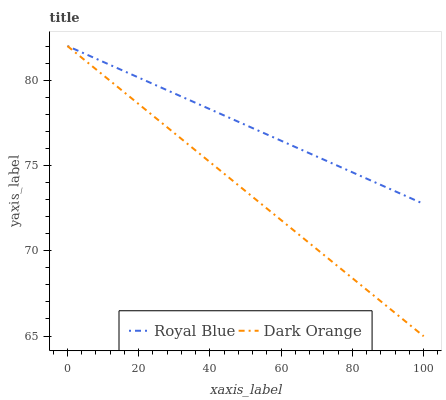Does Dark Orange have the minimum area under the curve?
Answer yes or no. Yes. Does Royal Blue have the maximum area under the curve?
Answer yes or no. Yes. Does Dark Orange have the maximum area under the curve?
Answer yes or no. No. Is Royal Blue the smoothest?
Answer yes or no. Yes. Is Dark Orange the roughest?
Answer yes or no. Yes. Is Dark Orange the smoothest?
Answer yes or no. No. Does Dark Orange have the lowest value?
Answer yes or no. Yes. Does Dark Orange have the highest value?
Answer yes or no. Yes. Does Dark Orange intersect Royal Blue?
Answer yes or no. Yes. Is Dark Orange less than Royal Blue?
Answer yes or no. No. Is Dark Orange greater than Royal Blue?
Answer yes or no. No. 